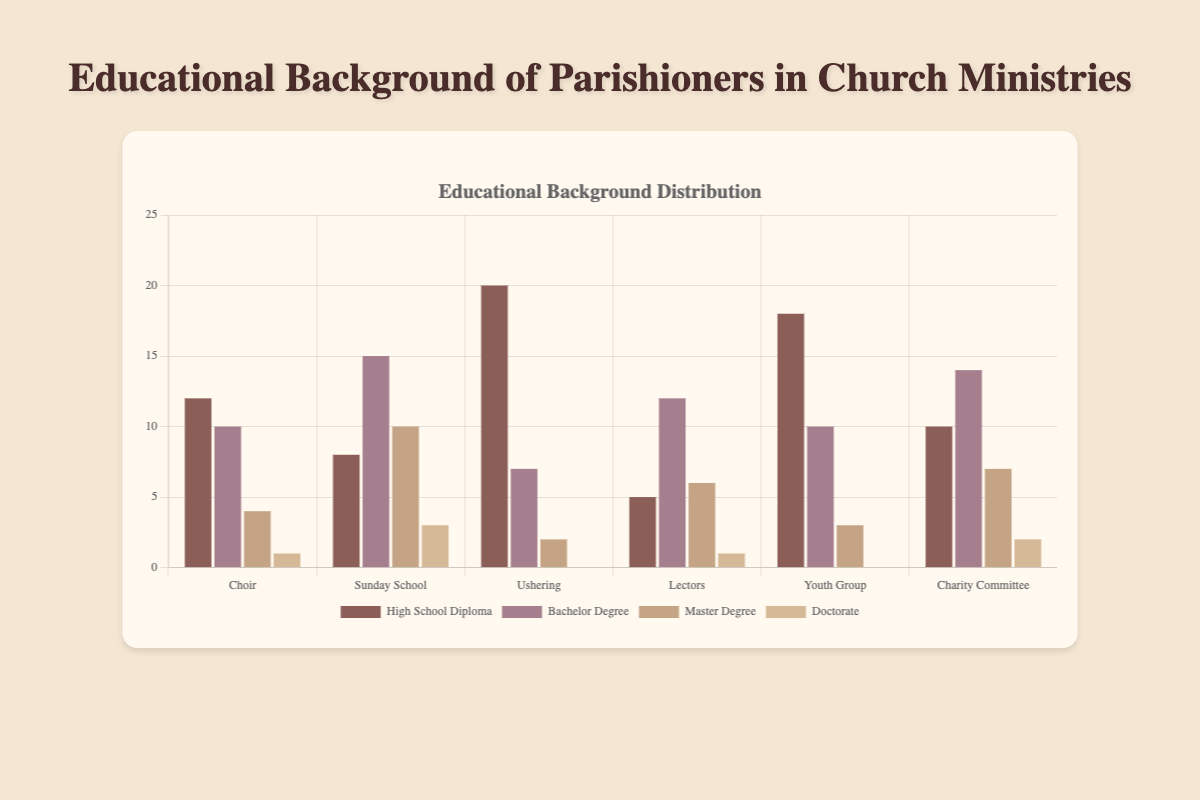Which ministry has the highest number of parishioners with a Bachelor Degree? To determine this, compare the heights of the bars labeled “Bachelor Degree” for each ministry. The bars for “Choir,” “Sunday School,” “Ushering,” “Lectors,” “Youth Group,” and “Charity Committee” are 10, 15, 7, 12, 10, and 14 units tall respectively. The highest bar is for “Sunday School” with 15.
Answer: Sunday School Which educational background is most common in the Youth Group ministry? Observe the bars labeled under “Youth Group.” The bars represent High School Diploma, Bachelor Degree, Master Degree, and Doctorate which are 18, 10, 3, and 0 units high respectively. The tallest bar is for High School Diploma.
Answer: High School Diploma How many more parishioners with a Doctorate degree are there in the Charity Committee than in the Ushering ministry? Identify the heights of the bars labeled “Doctorate” for “Charity Committee” and “Ushering.” “Charity Committee” is 2, and “Ushering” is 0. Subtract 0 from 2.
Answer: 2 Which two ministries have the same number of parishioners with a Master Degree? Compare the heights of the bars labeled “Master Degree” for each ministry. The heights are 4 (Choir), 10 (Sunday School), 2 (Ushering), 6 (Lectors), 3 (Youth Group), and 7 (Charity Committee). The values 2 and 2 match for “Ushering” and “Youth Group.”
Answer: None Compare the number of parishioners with a High School Diploma between the Choir and Ushering ministries. Which one has more and by how much? Look at the heights of the bars labeled “High School Diploma” under “Choir” and “Ushering.” The heights are 12 for Choir and 20 for Ushering. Subtract 12 from 20.
Answer: Ushering by 8 What is the total number of parishioners with a Bachelor Degree across all ministries? Sum the heights of all bars labeled “Bachelor Degree.” The values are 10 (Choir), 15 (Sunday School), 7 (Ushering), 12 (Lectors), 10 (Youth Group), and 14 (Charity Committee). The sum is 10 + 15 + 7 + 12 + 10 + 14 = 68.
Answer: 68 Is there any ministry without any parishioners with a Doctorate? If yes, which ministries are they? Check the heights of all bars labeled “Doctorate.” The heights are 1 (Choir), 3 (Sunday School), 0 (Ushering), 1 (Lectors), 0 (Youth Group), and 2 (Charity Committee). The ministries with a height of 0 are Ushering and Youth Group.
Answer: Ushering, Youth Group Which ministry has the least number of parishioners with a Master Degree? Compare the heights of the bars labeled “Master Degree” for each ministry. The heights are 4 (Choir), 10 (Sunday School), 2 (Ushering), 6 (Lectors), 3 (Youth Group), and 7 (Charity Committee). The smallest bar is for “Ushering” which is 2 units high.
Answer: Ushering What is the difference in the total number of parishioners between those with a Master Degree and those with a High School Diploma in the Lectors ministry? For the Lectors ministry, the heights of the bars are 6 (Master Degree) and 5 (High School Diploma). Subtract the height of the “High School Diploma” bar from the height of the “Master Degree” bar. The difference is 6 - 5.
Answer: 1 Across all ministries, which educational background has the highest total number of parishioners? Sum the heights of all bars for each educational background. High School Diploma is (12 + 8 + 20 + 5 + 18 + 10) = 73, Bachelor Degree is (10 + 15 + 7 + 12 + 10 + 14) = 68, Master Degree is (4 + 10 + 2 + 6 + 3 + 7) = 32, and Doctorate is (1 + 3 + 0 + 1 + 0 + 2) = 7. The highest total is for High School Diploma with 73.
Answer: High School Diploma 